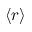<formula> <loc_0><loc_0><loc_500><loc_500>\langle r \rangle</formula> 